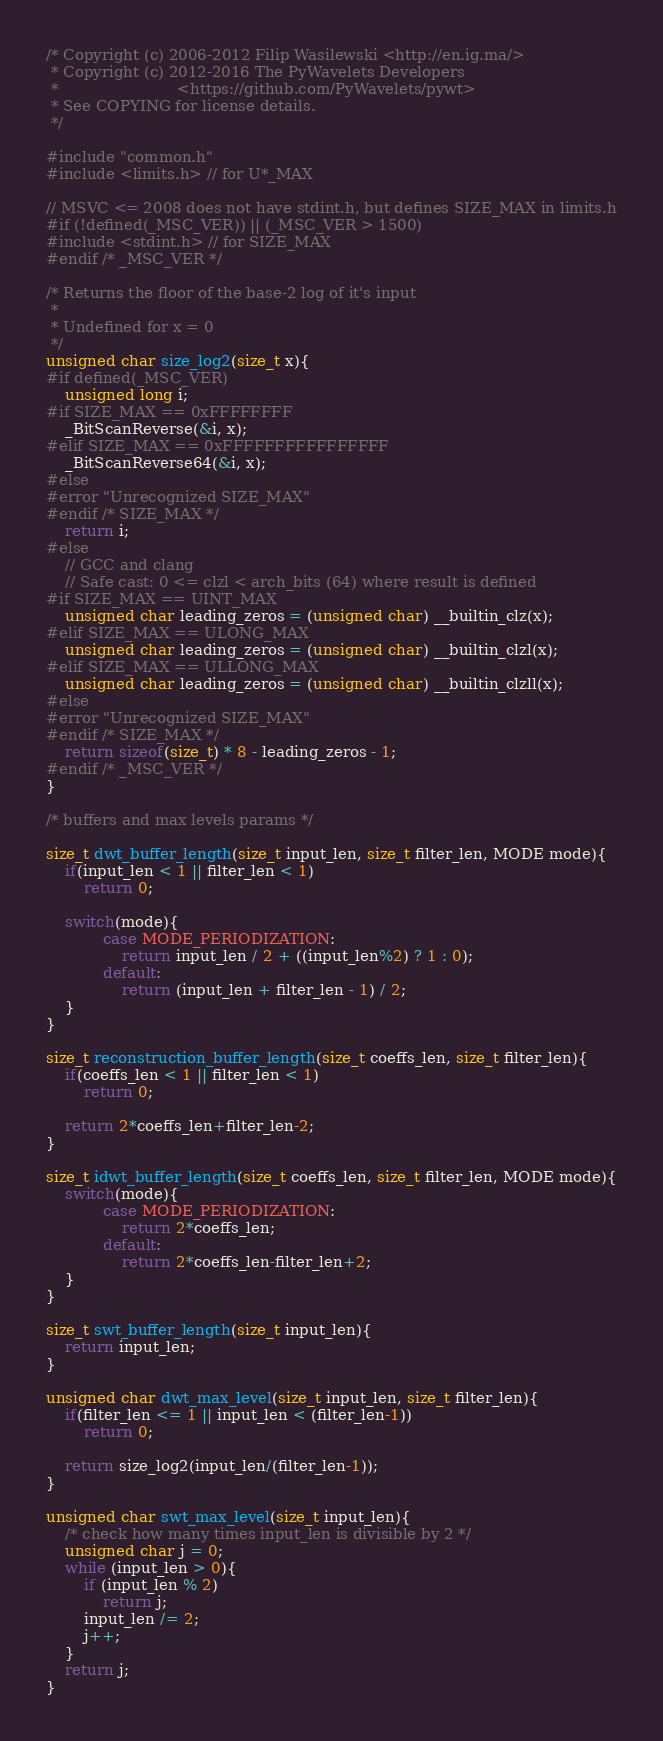<code> <loc_0><loc_0><loc_500><loc_500><_C_>/* Copyright (c) 2006-2012 Filip Wasilewski <http://en.ig.ma/>
 * Copyright (c) 2012-2016 The PyWavelets Developers
 *                         <https://github.com/PyWavelets/pywt>
 * See COPYING for license details.
 */

#include "common.h"
#include <limits.h> // for U*_MAX

// MSVC <= 2008 does not have stdint.h, but defines SIZE_MAX in limits.h
#if (!defined(_MSC_VER)) || (_MSC_VER > 1500)
#include <stdint.h> // for SIZE_MAX
#endif /* _MSC_VER */

/* Returns the floor of the base-2 log of it's input
 *
 * Undefined for x = 0
 */
unsigned char size_log2(size_t x){
#if defined(_MSC_VER)
    unsigned long i;
#if SIZE_MAX == 0xFFFFFFFF
    _BitScanReverse(&i, x);
#elif SIZE_MAX == 0xFFFFFFFFFFFFFFFF
    _BitScanReverse64(&i, x);
#else
#error "Unrecognized SIZE_MAX"
#endif /* SIZE_MAX */
    return i;
#else
    // GCC and clang
    // Safe cast: 0 <= clzl < arch_bits (64) where result is defined
#if SIZE_MAX == UINT_MAX
    unsigned char leading_zeros = (unsigned char) __builtin_clz(x);
#elif SIZE_MAX == ULONG_MAX
    unsigned char leading_zeros = (unsigned char) __builtin_clzl(x);
#elif SIZE_MAX == ULLONG_MAX
    unsigned char leading_zeros = (unsigned char) __builtin_clzll(x);
#else
#error "Unrecognized SIZE_MAX"
#endif /* SIZE_MAX */
    return sizeof(size_t) * 8 - leading_zeros - 1;
#endif /* _MSC_VER */
}

/* buffers and max levels params */

size_t dwt_buffer_length(size_t input_len, size_t filter_len, MODE mode){
    if(input_len < 1 || filter_len < 1)
        return 0;

    switch(mode){
            case MODE_PERIODIZATION:
                return input_len / 2 + ((input_len%2) ? 1 : 0);
            default:
                return (input_len + filter_len - 1) / 2;
    }
}

size_t reconstruction_buffer_length(size_t coeffs_len, size_t filter_len){
    if(coeffs_len < 1 || filter_len < 1)
        return 0;

    return 2*coeffs_len+filter_len-2;
}

size_t idwt_buffer_length(size_t coeffs_len, size_t filter_len, MODE mode){
    switch(mode){
            case MODE_PERIODIZATION:
                return 2*coeffs_len;
            default:
                return 2*coeffs_len-filter_len+2;
    }
}

size_t swt_buffer_length(size_t input_len){
    return input_len;
}

unsigned char dwt_max_level(size_t input_len, size_t filter_len){
    if(filter_len <= 1 || input_len < (filter_len-1))
        return 0;

    return size_log2(input_len/(filter_len-1));
}

unsigned char swt_max_level(size_t input_len){
    /* check how many times input_len is divisible by 2 */
    unsigned char j = 0;
    while (input_len > 0){
        if (input_len % 2)
            return j;
        input_len /= 2;
        j++;
    }
    return j;
}
</code> 